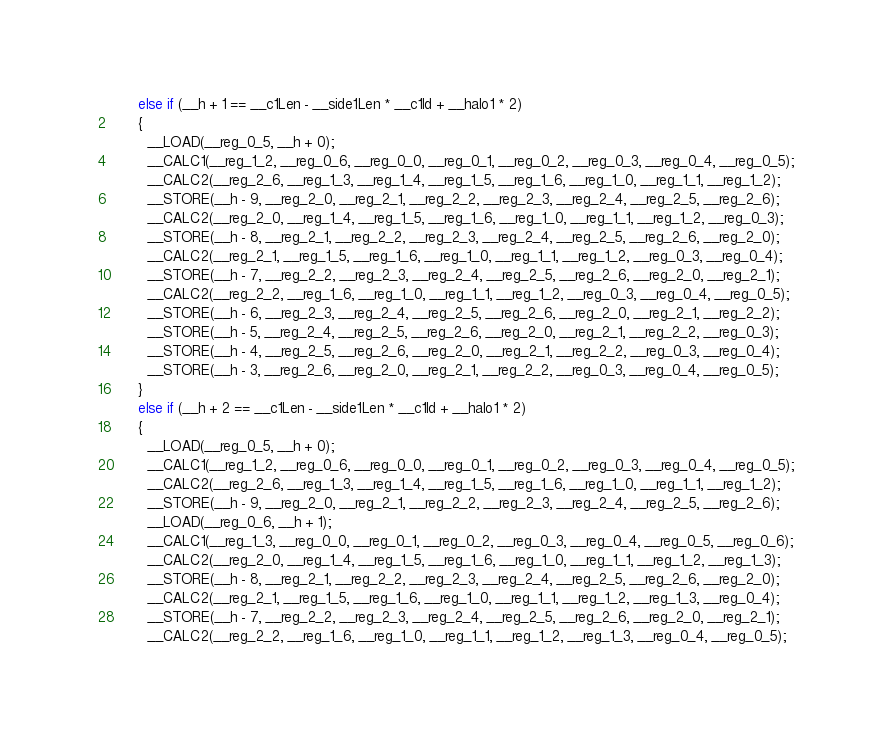Convert code to text. <code><loc_0><loc_0><loc_500><loc_500><_Cuda_>      else if (__h + 1 == __c1Len - __side1Len * __c1Id + __halo1 * 2)
      {
        __LOAD(__reg_0_5, __h + 0);
        __CALC1(__reg_1_2, __reg_0_6, __reg_0_0, __reg_0_1, __reg_0_2, __reg_0_3, __reg_0_4, __reg_0_5);
        __CALC2(__reg_2_6, __reg_1_3, __reg_1_4, __reg_1_5, __reg_1_6, __reg_1_0, __reg_1_1, __reg_1_2);
        __STORE(__h - 9, __reg_2_0, __reg_2_1, __reg_2_2, __reg_2_3, __reg_2_4, __reg_2_5, __reg_2_6);
        __CALC2(__reg_2_0, __reg_1_4, __reg_1_5, __reg_1_6, __reg_1_0, __reg_1_1, __reg_1_2, __reg_0_3);
        __STORE(__h - 8, __reg_2_1, __reg_2_2, __reg_2_3, __reg_2_4, __reg_2_5, __reg_2_6, __reg_2_0);
        __CALC2(__reg_2_1, __reg_1_5, __reg_1_6, __reg_1_0, __reg_1_1, __reg_1_2, __reg_0_3, __reg_0_4);
        __STORE(__h - 7, __reg_2_2, __reg_2_3, __reg_2_4, __reg_2_5, __reg_2_6, __reg_2_0, __reg_2_1);
        __CALC2(__reg_2_2, __reg_1_6, __reg_1_0, __reg_1_1, __reg_1_2, __reg_0_3, __reg_0_4, __reg_0_5);
        __STORE(__h - 6, __reg_2_3, __reg_2_4, __reg_2_5, __reg_2_6, __reg_2_0, __reg_2_1, __reg_2_2);
        __STORE(__h - 5, __reg_2_4, __reg_2_5, __reg_2_6, __reg_2_0, __reg_2_1, __reg_2_2, __reg_0_3);
        __STORE(__h - 4, __reg_2_5, __reg_2_6, __reg_2_0, __reg_2_1, __reg_2_2, __reg_0_3, __reg_0_4);
        __STORE(__h - 3, __reg_2_6, __reg_2_0, __reg_2_1, __reg_2_2, __reg_0_3, __reg_0_4, __reg_0_5);
      }
      else if (__h + 2 == __c1Len - __side1Len * __c1Id + __halo1 * 2)
      {
        __LOAD(__reg_0_5, __h + 0);
        __CALC1(__reg_1_2, __reg_0_6, __reg_0_0, __reg_0_1, __reg_0_2, __reg_0_3, __reg_0_4, __reg_0_5);
        __CALC2(__reg_2_6, __reg_1_3, __reg_1_4, __reg_1_5, __reg_1_6, __reg_1_0, __reg_1_1, __reg_1_2);
        __STORE(__h - 9, __reg_2_0, __reg_2_1, __reg_2_2, __reg_2_3, __reg_2_4, __reg_2_5, __reg_2_6);
        __LOAD(__reg_0_6, __h + 1);
        __CALC1(__reg_1_3, __reg_0_0, __reg_0_1, __reg_0_2, __reg_0_3, __reg_0_4, __reg_0_5, __reg_0_6);
        __CALC2(__reg_2_0, __reg_1_4, __reg_1_5, __reg_1_6, __reg_1_0, __reg_1_1, __reg_1_2, __reg_1_3);
        __STORE(__h - 8, __reg_2_1, __reg_2_2, __reg_2_3, __reg_2_4, __reg_2_5, __reg_2_6, __reg_2_0);
        __CALC2(__reg_2_1, __reg_1_5, __reg_1_6, __reg_1_0, __reg_1_1, __reg_1_2, __reg_1_3, __reg_0_4);
        __STORE(__h - 7, __reg_2_2, __reg_2_3, __reg_2_4, __reg_2_5, __reg_2_6, __reg_2_0, __reg_2_1);
        __CALC2(__reg_2_2, __reg_1_6, __reg_1_0, __reg_1_1, __reg_1_2, __reg_1_3, __reg_0_4, __reg_0_5);</code> 